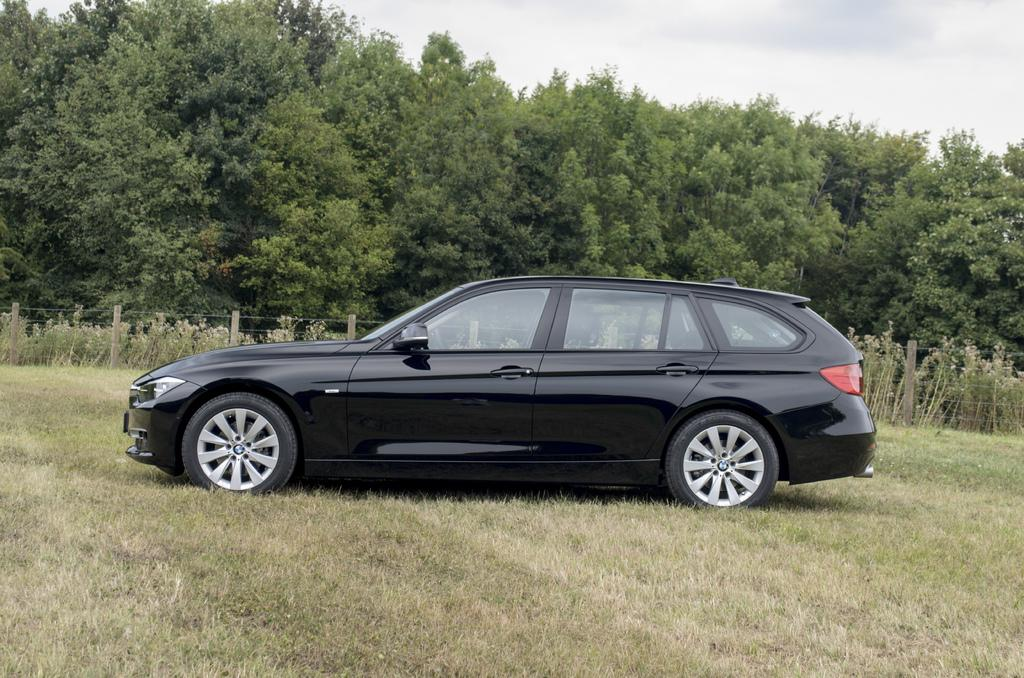What color is the car in the image? The car in the image is black. Where is the car located in the image? The car is on a greenery ground. What is beside the car in the image? There is a fence beside the car. What can be seen in the background of the image? There are trees in the background of the image. What role does the actor play in the image? There is no actor present in the image; it features a black car on a greenery ground with a fence beside it and trees in the background. 